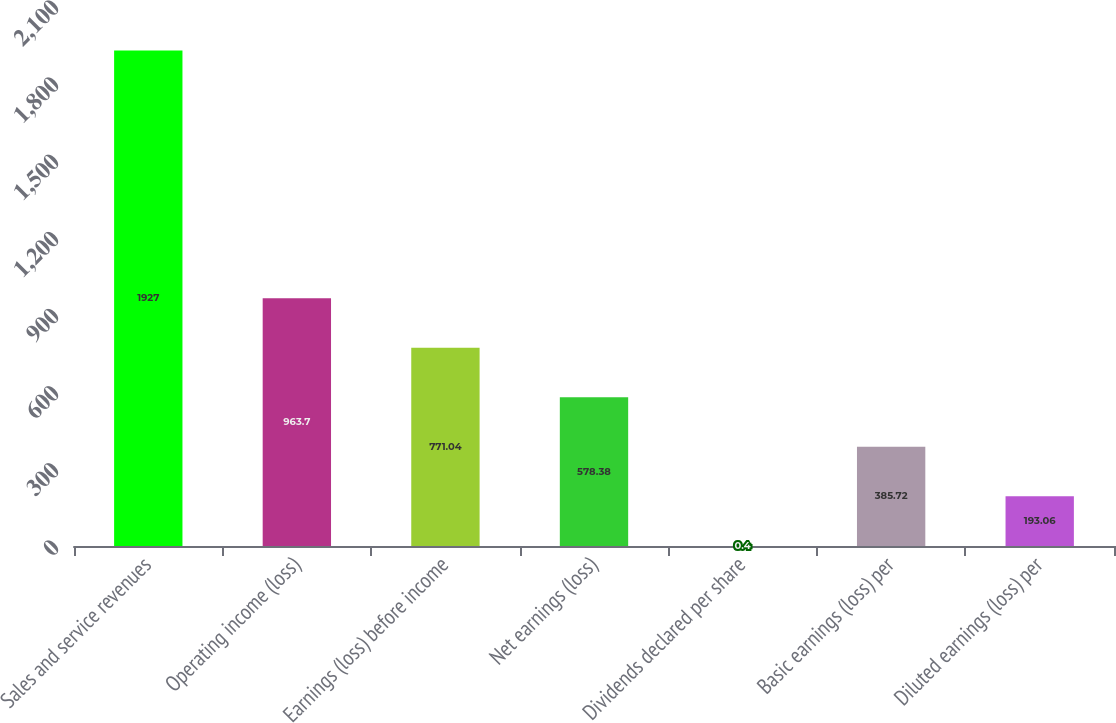<chart> <loc_0><loc_0><loc_500><loc_500><bar_chart><fcel>Sales and service revenues<fcel>Operating income (loss)<fcel>Earnings (loss) before income<fcel>Net earnings (loss)<fcel>Dividends declared per share<fcel>Basic earnings (loss) per<fcel>Diluted earnings (loss) per<nl><fcel>1927<fcel>963.7<fcel>771.04<fcel>578.38<fcel>0.4<fcel>385.72<fcel>193.06<nl></chart> 